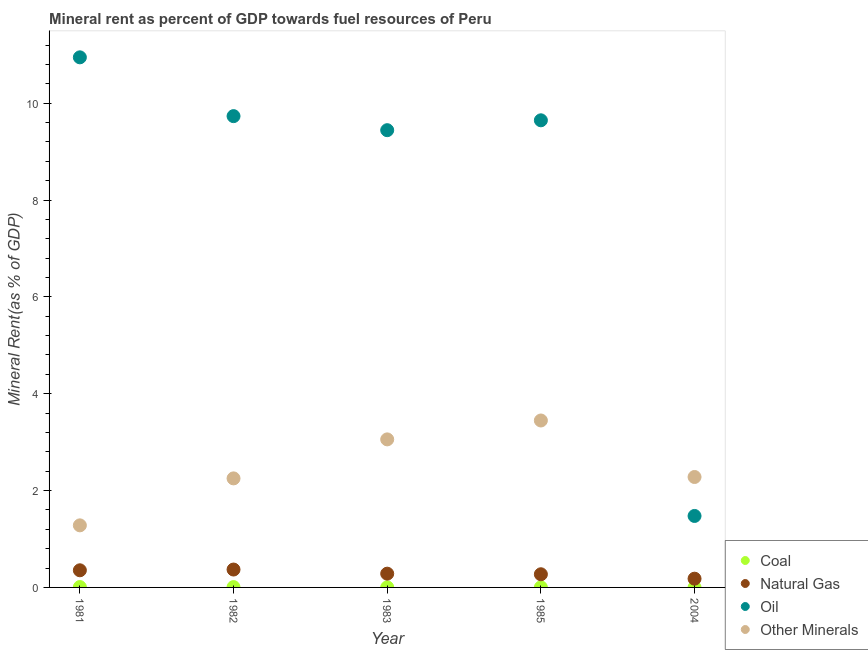How many different coloured dotlines are there?
Your response must be concise. 4. Is the number of dotlines equal to the number of legend labels?
Offer a terse response. Yes. What is the coal rent in 1985?
Ensure brevity in your answer.  0. Across all years, what is the maximum coal rent?
Your answer should be very brief. 0.01. Across all years, what is the minimum coal rent?
Provide a short and direct response. 0. In which year was the oil rent minimum?
Your answer should be very brief. 2004. What is the total oil rent in the graph?
Keep it short and to the point. 41.24. What is the difference between the coal rent in 1981 and that in 1985?
Offer a very short reply. 0.01. What is the difference between the natural gas rent in 1981 and the coal rent in 2004?
Offer a very short reply. 0.35. What is the average  rent of other minerals per year?
Your answer should be compact. 2.46. In the year 1982, what is the difference between the natural gas rent and coal rent?
Your response must be concise. 0.36. What is the ratio of the coal rent in 1981 to that in 1983?
Offer a terse response. 3.55. Is the difference between the oil rent in 1983 and 2004 greater than the difference between the natural gas rent in 1983 and 2004?
Keep it short and to the point. Yes. What is the difference between the highest and the second highest coal rent?
Give a very brief answer. 0. What is the difference between the highest and the lowest natural gas rent?
Give a very brief answer. 0.19. Is it the case that in every year, the sum of the coal rent and natural gas rent is greater than the oil rent?
Provide a short and direct response. No. Does the coal rent monotonically increase over the years?
Give a very brief answer. No. Is the oil rent strictly greater than the natural gas rent over the years?
Keep it short and to the point. Yes. How many years are there in the graph?
Ensure brevity in your answer.  5. Where does the legend appear in the graph?
Offer a very short reply. Bottom right. How many legend labels are there?
Keep it short and to the point. 4. What is the title of the graph?
Offer a very short reply. Mineral rent as percent of GDP towards fuel resources of Peru. What is the label or title of the X-axis?
Offer a terse response. Year. What is the label or title of the Y-axis?
Ensure brevity in your answer.  Mineral Rent(as % of GDP). What is the Mineral Rent(as % of GDP) in Coal in 1981?
Provide a succinct answer. 0.01. What is the Mineral Rent(as % of GDP) of Natural Gas in 1981?
Provide a succinct answer. 0.35. What is the Mineral Rent(as % of GDP) of Oil in 1981?
Offer a very short reply. 10.95. What is the Mineral Rent(as % of GDP) in Other Minerals in 1981?
Give a very brief answer. 1.28. What is the Mineral Rent(as % of GDP) of Coal in 1982?
Give a very brief answer. 0.01. What is the Mineral Rent(as % of GDP) in Natural Gas in 1982?
Provide a short and direct response. 0.37. What is the Mineral Rent(as % of GDP) in Oil in 1982?
Provide a succinct answer. 9.73. What is the Mineral Rent(as % of GDP) in Other Minerals in 1982?
Your answer should be compact. 2.25. What is the Mineral Rent(as % of GDP) in Coal in 1983?
Give a very brief answer. 0. What is the Mineral Rent(as % of GDP) in Natural Gas in 1983?
Provide a short and direct response. 0.28. What is the Mineral Rent(as % of GDP) of Oil in 1983?
Your answer should be compact. 9.44. What is the Mineral Rent(as % of GDP) in Other Minerals in 1983?
Offer a terse response. 3.06. What is the Mineral Rent(as % of GDP) in Coal in 1985?
Ensure brevity in your answer.  0. What is the Mineral Rent(as % of GDP) in Natural Gas in 1985?
Ensure brevity in your answer.  0.27. What is the Mineral Rent(as % of GDP) of Oil in 1985?
Your response must be concise. 9.65. What is the Mineral Rent(as % of GDP) in Other Minerals in 1985?
Offer a very short reply. 3.45. What is the Mineral Rent(as % of GDP) of Coal in 2004?
Your answer should be compact. 0. What is the Mineral Rent(as % of GDP) of Natural Gas in 2004?
Make the answer very short. 0.18. What is the Mineral Rent(as % of GDP) of Oil in 2004?
Make the answer very short. 1.48. What is the Mineral Rent(as % of GDP) of Other Minerals in 2004?
Give a very brief answer. 2.28. Across all years, what is the maximum Mineral Rent(as % of GDP) in Coal?
Ensure brevity in your answer.  0.01. Across all years, what is the maximum Mineral Rent(as % of GDP) of Natural Gas?
Offer a very short reply. 0.37. Across all years, what is the maximum Mineral Rent(as % of GDP) of Oil?
Provide a succinct answer. 10.95. Across all years, what is the maximum Mineral Rent(as % of GDP) of Other Minerals?
Offer a terse response. 3.45. Across all years, what is the minimum Mineral Rent(as % of GDP) of Coal?
Provide a short and direct response. 0. Across all years, what is the minimum Mineral Rent(as % of GDP) in Natural Gas?
Give a very brief answer. 0.18. Across all years, what is the minimum Mineral Rent(as % of GDP) in Oil?
Your answer should be very brief. 1.48. Across all years, what is the minimum Mineral Rent(as % of GDP) in Other Minerals?
Your answer should be compact. 1.28. What is the total Mineral Rent(as % of GDP) of Coal in the graph?
Your answer should be very brief. 0.02. What is the total Mineral Rent(as % of GDP) of Natural Gas in the graph?
Make the answer very short. 1.46. What is the total Mineral Rent(as % of GDP) of Oil in the graph?
Offer a very short reply. 41.24. What is the total Mineral Rent(as % of GDP) in Other Minerals in the graph?
Provide a short and direct response. 12.32. What is the difference between the Mineral Rent(as % of GDP) in Coal in 1981 and that in 1982?
Your answer should be very brief. 0. What is the difference between the Mineral Rent(as % of GDP) in Natural Gas in 1981 and that in 1982?
Keep it short and to the point. -0.02. What is the difference between the Mineral Rent(as % of GDP) in Oil in 1981 and that in 1982?
Provide a succinct answer. 1.21. What is the difference between the Mineral Rent(as % of GDP) in Other Minerals in 1981 and that in 1982?
Your answer should be compact. -0.97. What is the difference between the Mineral Rent(as % of GDP) of Coal in 1981 and that in 1983?
Your response must be concise. 0.01. What is the difference between the Mineral Rent(as % of GDP) in Natural Gas in 1981 and that in 1983?
Give a very brief answer. 0.07. What is the difference between the Mineral Rent(as % of GDP) in Oil in 1981 and that in 1983?
Offer a terse response. 1.5. What is the difference between the Mineral Rent(as % of GDP) of Other Minerals in 1981 and that in 1983?
Your response must be concise. -1.78. What is the difference between the Mineral Rent(as % of GDP) of Coal in 1981 and that in 1985?
Give a very brief answer. 0.01. What is the difference between the Mineral Rent(as % of GDP) of Natural Gas in 1981 and that in 1985?
Your response must be concise. 0.08. What is the difference between the Mineral Rent(as % of GDP) of Oil in 1981 and that in 1985?
Keep it short and to the point. 1.3. What is the difference between the Mineral Rent(as % of GDP) of Other Minerals in 1981 and that in 1985?
Make the answer very short. -2.17. What is the difference between the Mineral Rent(as % of GDP) of Coal in 1981 and that in 2004?
Offer a terse response. 0.01. What is the difference between the Mineral Rent(as % of GDP) of Natural Gas in 1981 and that in 2004?
Provide a short and direct response. 0.17. What is the difference between the Mineral Rent(as % of GDP) in Oil in 1981 and that in 2004?
Provide a succinct answer. 9.47. What is the difference between the Mineral Rent(as % of GDP) of Other Minerals in 1981 and that in 2004?
Make the answer very short. -1. What is the difference between the Mineral Rent(as % of GDP) in Coal in 1982 and that in 1983?
Your response must be concise. 0. What is the difference between the Mineral Rent(as % of GDP) of Natural Gas in 1982 and that in 1983?
Offer a terse response. 0.09. What is the difference between the Mineral Rent(as % of GDP) of Oil in 1982 and that in 1983?
Your answer should be compact. 0.29. What is the difference between the Mineral Rent(as % of GDP) of Other Minerals in 1982 and that in 1983?
Provide a short and direct response. -0.81. What is the difference between the Mineral Rent(as % of GDP) in Coal in 1982 and that in 1985?
Offer a very short reply. 0.01. What is the difference between the Mineral Rent(as % of GDP) of Natural Gas in 1982 and that in 1985?
Offer a terse response. 0.1. What is the difference between the Mineral Rent(as % of GDP) in Oil in 1982 and that in 1985?
Offer a very short reply. 0.09. What is the difference between the Mineral Rent(as % of GDP) of Other Minerals in 1982 and that in 1985?
Your answer should be very brief. -1.2. What is the difference between the Mineral Rent(as % of GDP) of Coal in 1982 and that in 2004?
Offer a terse response. 0.01. What is the difference between the Mineral Rent(as % of GDP) of Natural Gas in 1982 and that in 2004?
Offer a terse response. 0.19. What is the difference between the Mineral Rent(as % of GDP) in Oil in 1982 and that in 2004?
Offer a very short reply. 8.26. What is the difference between the Mineral Rent(as % of GDP) of Other Minerals in 1982 and that in 2004?
Your answer should be compact. -0.03. What is the difference between the Mineral Rent(as % of GDP) of Coal in 1983 and that in 1985?
Provide a short and direct response. 0. What is the difference between the Mineral Rent(as % of GDP) in Natural Gas in 1983 and that in 1985?
Provide a succinct answer. 0.01. What is the difference between the Mineral Rent(as % of GDP) in Oil in 1983 and that in 1985?
Your answer should be very brief. -0.2. What is the difference between the Mineral Rent(as % of GDP) in Other Minerals in 1983 and that in 1985?
Your answer should be very brief. -0.39. What is the difference between the Mineral Rent(as % of GDP) of Coal in 1983 and that in 2004?
Your answer should be very brief. 0. What is the difference between the Mineral Rent(as % of GDP) in Natural Gas in 1983 and that in 2004?
Your answer should be very brief. 0.1. What is the difference between the Mineral Rent(as % of GDP) in Oil in 1983 and that in 2004?
Make the answer very short. 7.97. What is the difference between the Mineral Rent(as % of GDP) of Other Minerals in 1983 and that in 2004?
Offer a very short reply. 0.78. What is the difference between the Mineral Rent(as % of GDP) in Coal in 1985 and that in 2004?
Provide a short and direct response. 0. What is the difference between the Mineral Rent(as % of GDP) in Natural Gas in 1985 and that in 2004?
Provide a succinct answer. 0.09. What is the difference between the Mineral Rent(as % of GDP) in Oil in 1985 and that in 2004?
Ensure brevity in your answer.  8.17. What is the difference between the Mineral Rent(as % of GDP) of Other Minerals in 1985 and that in 2004?
Your answer should be compact. 1.17. What is the difference between the Mineral Rent(as % of GDP) in Coal in 1981 and the Mineral Rent(as % of GDP) in Natural Gas in 1982?
Provide a short and direct response. -0.36. What is the difference between the Mineral Rent(as % of GDP) in Coal in 1981 and the Mineral Rent(as % of GDP) in Oil in 1982?
Offer a terse response. -9.72. What is the difference between the Mineral Rent(as % of GDP) in Coal in 1981 and the Mineral Rent(as % of GDP) in Other Minerals in 1982?
Offer a very short reply. -2.24. What is the difference between the Mineral Rent(as % of GDP) of Natural Gas in 1981 and the Mineral Rent(as % of GDP) of Oil in 1982?
Make the answer very short. -9.38. What is the difference between the Mineral Rent(as % of GDP) of Natural Gas in 1981 and the Mineral Rent(as % of GDP) of Other Minerals in 1982?
Your response must be concise. -1.9. What is the difference between the Mineral Rent(as % of GDP) in Oil in 1981 and the Mineral Rent(as % of GDP) in Other Minerals in 1982?
Your answer should be very brief. 8.69. What is the difference between the Mineral Rent(as % of GDP) of Coal in 1981 and the Mineral Rent(as % of GDP) of Natural Gas in 1983?
Offer a very short reply. -0.28. What is the difference between the Mineral Rent(as % of GDP) of Coal in 1981 and the Mineral Rent(as % of GDP) of Oil in 1983?
Offer a very short reply. -9.43. What is the difference between the Mineral Rent(as % of GDP) of Coal in 1981 and the Mineral Rent(as % of GDP) of Other Minerals in 1983?
Keep it short and to the point. -3.05. What is the difference between the Mineral Rent(as % of GDP) in Natural Gas in 1981 and the Mineral Rent(as % of GDP) in Oil in 1983?
Keep it short and to the point. -9.09. What is the difference between the Mineral Rent(as % of GDP) of Natural Gas in 1981 and the Mineral Rent(as % of GDP) of Other Minerals in 1983?
Offer a very short reply. -2.7. What is the difference between the Mineral Rent(as % of GDP) of Oil in 1981 and the Mineral Rent(as % of GDP) of Other Minerals in 1983?
Keep it short and to the point. 7.89. What is the difference between the Mineral Rent(as % of GDP) in Coal in 1981 and the Mineral Rent(as % of GDP) in Natural Gas in 1985?
Offer a very short reply. -0.26. What is the difference between the Mineral Rent(as % of GDP) of Coal in 1981 and the Mineral Rent(as % of GDP) of Oil in 1985?
Offer a very short reply. -9.64. What is the difference between the Mineral Rent(as % of GDP) in Coal in 1981 and the Mineral Rent(as % of GDP) in Other Minerals in 1985?
Your response must be concise. -3.44. What is the difference between the Mineral Rent(as % of GDP) of Natural Gas in 1981 and the Mineral Rent(as % of GDP) of Oil in 1985?
Ensure brevity in your answer.  -9.29. What is the difference between the Mineral Rent(as % of GDP) in Natural Gas in 1981 and the Mineral Rent(as % of GDP) in Other Minerals in 1985?
Ensure brevity in your answer.  -3.09. What is the difference between the Mineral Rent(as % of GDP) of Oil in 1981 and the Mineral Rent(as % of GDP) of Other Minerals in 1985?
Provide a succinct answer. 7.5. What is the difference between the Mineral Rent(as % of GDP) of Coal in 1981 and the Mineral Rent(as % of GDP) of Natural Gas in 2004?
Your answer should be very brief. -0.17. What is the difference between the Mineral Rent(as % of GDP) in Coal in 1981 and the Mineral Rent(as % of GDP) in Oil in 2004?
Keep it short and to the point. -1.47. What is the difference between the Mineral Rent(as % of GDP) in Coal in 1981 and the Mineral Rent(as % of GDP) in Other Minerals in 2004?
Offer a very short reply. -2.27. What is the difference between the Mineral Rent(as % of GDP) in Natural Gas in 1981 and the Mineral Rent(as % of GDP) in Oil in 2004?
Your answer should be compact. -1.12. What is the difference between the Mineral Rent(as % of GDP) of Natural Gas in 1981 and the Mineral Rent(as % of GDP) of Other Minerals in 2004?
Your answer should be very brief. -1.93. What is the difference between the Mineral Rent(as % of GDP) in Oil in 1981 and the Mineral Rent(as % of GDP) in Other Minerals in 2004?
Offer a very short reply. 8.67. What is the difference between the Mineral Rent(as % of GDP) in Coal in 1982 and the Mineral Rent(as % of GDP) in Natural Gas in 1983?
Provide a succinct answer. -0.28. What is the difference between the Mineral Rent(as % of GDP) of Coal in 1982 and the Mineral Rent(as % of GDP) of Oil in 1983?
Give a very brief answer. -9.44. What is the difference between the Mineral Rent(as % of GDP) of Coal in 1982 and the Mineral Rent(as % of GDP) of Other Minerals in 1983?
Your answer should be very brief. -3.05. What is the difference between the Mineral Rent(as % of GDP) of Natural Gas in 1982 and the Mineral Rent(as % of GDP) of Oil in 1983?
Ensure brevity in your answer.  -9.07. What is the difference between the Mineral Rent(as % of GDP) in Natural Gas in 1982 and the Mineral Rent(as % of GDP) in Other Minerals in 1983?
Provide a succinct answer. -2.69. What is the difference between the Mineral Rent(as % of GDP) in Oil in 1982 and the Mineral Rent(as % of GDP) in Other Minerals in 1983?
Give a very brief answer. 6.68. What is the difference between the Mineral Rent(as % of GDP) in Coal in 1982 and the Mineral Rent(as % of GDP) in Natural Gas in 1985?
Offer a terse response. -0.27. What is the difference between the Mineral Rent(as % of GDP) in Coal in 1982 and the Mineral Rent(as % of GDP) in Oil in 1985?
Your response must be concise. -9.64. What is the difference between the Mineral Rent(as % of GDP) of Coal in 1982 and the Mineral Rent(as % of GDP) of Other Minerals in 1985?
Your answer should be very brief. -3.44. What is the difference between the Mineral Rent(as % of GDP) of Natural Gas in 1982 and the Mineral Rent(as % of GDP) of Oil in 1985?
Your response must be concise. -9.28. What is the difference between the Mineral Rent(as % of GDP) of Natural Gas in 1982 and the Mineral Rent(as % of GDP) of Other Minerals in 1985?
Offer a terse response. -3.08. What is the difference between the Mineral Rent(as % of GDP) of Oil in 1982 and the Mineral Rent(as % of GDP) of Other Minerals in 1985?
Your response must be concise. 6.29. What is the difference between the Mineral Rent(as % of GDP) in Coal in 1982 and the Mineral Rent(as % of GDP) in Natural Gas in 2004?
Ensure brevity in your answer.  -0.17. What is the difference between the Mineral Rent(as % of GDP) in Coal in 1982 and the Mineral Rent(as % of GDP) in Oil in 2004?
Keep it short and to the point. -1.47. What is the difference between the Mineral Rent(as % of GDP) of Coal in 1982 and the Mineral Rent(as % of GDP) of Other Minerals in 2004?
Provide a short and direct response. -2.27. What is the difference between the Mineral Rent(as % of GDP) in Natural Gas in 1982 and the Mineral Rent(as % of GDP) in Oil in 2004?
Give a very brief answer. -1.11. What is the difference between the Mineral Rent(as % of GDP) in Natural Gas in 1982 and the Mineral Rent(as % of GDP) in Other Minerals in 2004?
Your answer should be very brief. -1.91. What is the difference between the Mineral Rent(as % of GDP) of Oil in 1982 and the Mineral Rent(as % of GDP) of Other Minerals in 2004?
Provide a short and direct response. 7.45. What is the difference between the Mineral Rent(as % of GDP) of Coal in 1983 and the Mineral Rent(as % of GDP) of Natural Gas in 1985?
Offer a terse response. -0.27. What is the difference between the Mineral Rent(as % of GDP) of Coal in 1983 and the Mineral Rent(as % of GDP) of Oil in 1985?
Make the answer very short. -9.64. What is the difference between the Mineral Rent(as % of GDP) in Coal in 1983 and the Mineral Rent(as % of GDP) in Other Minerals in 1985?
Your response must be concise. -3.44. What is the difference between the Mineral Rent(as % of GDP) in Natural Gas in 1983 and the Mineral Rent(as % of GDP) in Oil in 1985?
Provide a succinct answer. -9.36. What is the difference between the Mineral Rent(as % of GDP) of Natural Gas in 1983 and the Mineral Rent(as % of GDP) of Other Minerals in 1985?
Your answer should be very brief. -3.16. What is the difference between the Mineral Rent(as % of GDP) of Oil in 1983 and the Mineral Rent(as % of GDP) of Other Minerals in 1985?
Give a very brief answer. 6. What is the difference between the Mineral Rent(as % of GDP) in Coal in 1983 and the Mineral Rent(as % of GDP) in Natural Gas in 2004?
Give a very brief answer. -0.18. What is the difference between the Mineral Rent(as % of GDP) of Coal in 1983 and the Mineral Rent(as % of GDP) of Oil in 2004?
Your response must be concise. -1.47. What is the difference between the Mineral Rent(as % of GDP) in Coal in 1983 and the Mineral Rent(as % of GDP) in Other Minerals in 2004?
Ensure brevity in your answer.  -2.28. What is the difference between the Mineral Rent(as % of GDP) in Natural Gas in 1983 and the Mineral Rent(as % of GDP) in Oil in 2004?
Provide a short and direct response. -1.19. What is the difference between the Mineral Rent(as % of GDP) in Natural Gas in 1983 and the Mineral Rent(as % of GDP) in Other Minerals in 2004?
Provide a short and direct response. -2. What is the difference between the Mineral Rent(as % of GDP) of Oil in 1983 and the Mineral Rent(as % of GDP) of Other Minerals in 2004?
Your answer should be very brief. 7.16. What is the difference between the Mineral Rent(as % of GDP) of Coal in 1985 and the Mineral Rent(as % of GDP) of Natural Gas in 2004?
Ensure brevity in your answer.  -0.18. What is the difference between the Mineral Rent(as % of GDP) in Coal in 1985 and the Mineral Rent(as % of GDP) in Oil in 2004?
Your answer should be very brief. -1.47. What is the difference between the Mineral Rent(as % of GDP) in Coal in 1985 and the Mineral Rent(as % of GDP) in Other Minerals in 2004?
Give a very brief answer. -2.28. What is the difference between the Mineral Rent(as % of GDP) in Natural Gas in 1985 and the Mineral Rent(as % of GDP) in Oil in 2004?
Your response must be concise. -1.2. What is the difference between the Mineral Rent(as % of GDP) of Natural Gas in 1985 and the Mineral Rent(as % of GDP) of Other Minerals in 2004?
Give a very brief answer. -2.01. What is the difference between the Mineral Rent(as % of GDP) of Oil in 1985 and the Mineral Rent(as % of GDP) of Other Minerals in 2004?
Provide a short and direct response. 7.37. What is the average Mineral Rent(as % of GDP) in Coal per year?
Offer a terse response. 0. What is the average Mineral Rent(as % of GDP) of Natural Gas per year?
Make the answer very short. 0.29. What is the average Mineral Rent(as % of GDP) in Oil per year?
Ensure brevity in your answer.  8.25. What is the average Mineral Rent(as % of GDP) in Other Minerals per year?
Offer a very short reply. 2.46. In the year 1981, what is the difference between the Mineral Rent(as % of GDP) in Coal and Mineral Rent(as % of GDP) in Natural Gas?
Make the answer very short. -0.35. In the year 1981, what is the difference between the Mineral Rent(as % of GDP) of Coal and Mineral Rent(as % of GDP) of Oil?
Your answer should be compact. -10.94. In the year 1981, what is the difference between the Mineral Rent(as % of GDP) in Coal and Mineral Rent(as % of GDP) in Other Minerals?
Keep it short and to the point. -1.27. In the year 1981, what is the difference between the Mineral Rent(as % of GDP) in Natural Gas and Mineral Rent(as % of GDP) in Oil?
Offer a terse response. -10.59. In the year 1981, what is the difference between the Mineral Rent(as % of GDP) of Natural Gas and Mineral Rent(as % of GDP) of Other Minerals?
Make the answer very short. -0.93. In the year 1981, what is the difference between the Mineral Rent(as % of GDP) in Oil and Mineral Rent(as % of GDP) in Other Minerals?
Give a very brief answer. 9.66. In the year 1982, what is the difference between the Mineral Rent(as % of GDP) of Coal and Mineral Rent(as % of GDP) of Natural Gas?
Provide a succinct answer. -0.36. In the year 1982, what is the difference between the Mineral Rent(as % of GDP) of Coal and Mineral Rent(as % of GDP) of Oil?
Give a very brief answer. -9.73. In the year 1982, what is the difference between the Mineral Rent(as % of GDP) in Coal and Mineral Rent(as % of GDP) in Other Minerals?
Give a very brief answer. -2.24. In the year 1982, what is the difference between the Mineral Rent(as % of GDP) in Natural Gas and Mineral Rent(as % of GDP) in Oil?
Offer a terse response. -9.36. In the year 1982, what is the difference between the Mineral Rent(as % of GDP) in Natural Gas and Mineral Rent(as % of GDP) in Other Minerals?
Make the answer very short. -1.88. In the year 1982, what is the difference between the Mineral Rent(as % of GDP) in Oil and Mineral Rent(as % of GDP) in Other Minerals?
Your answer should be very brief. 7.48. In the year 1983, what is the difference between the Mineral Rent(as % of GDP) in Coal and Mineral Rent(as % of GDP) in Natural Gas?
Keep it short and to the point. -0.28. In the year 1983, what is the difference between the Mineral Rent(as % of GDP) of Coal and Mineral Rent(as % of GDP) of Oil?
Your answer should be compact. -9.44. In the year 1983, what is the difference between the Mineral Rent(as % of GDP) of Coal and Mineral Rent(as % of GDP) of Other Minerals?
Your answer should be very brief. -3.05. In the year 1983, what is the difference between the Mineral Rent(as % of GDP) in Natural Gas and Mineral Rent(as % of GDP) in Oil?
Your response must be concise. -9.16. In the year 1983, what is the difference between the Mineral Rent(as % of GDP) in Natural Gas and Mineral Rent(as % of GDP) in Other Minerals?
Offer a terse response. -2.77. In the year 1983, what is the difference between the Mineral Rent(as % of GDP) of Oil and Mineral Rent(as % of GDP) of Other Minerals?
Provide a succinct answer. 6.38. In the year 1985, what is the difference between the Mineral Rent(as % of GDP) of Coal and Mineral Rent(as % of GDP) of Natural Gas?
Offer a very short reply. -0.27. In the year 1985, what is the difference between the Mineral Rent(as % of GDP) of Coal and Mineral Rent(as % of GDP) of Oil?
Ensure brevity in your answer.  -9.64. In the year 1985, what is the difference between the Mineral Rent(as % of GDP) in Coal and Mineral Rent(as % of GDP) in Other Minerals?
Your response must be concise. -3.45. In the year 1985, what is the difference between the Mineral Rent(as % of GDP) of Natural Gas and Mineral Rent(as % of GDP) of Oil?
Keep it short and to the point. -9.37. In the year 1985, what is the difference between the Mineral Rent(as % of GDP) of Natural Gas and Mineral Rent(as % of GDP) of Other Minerals?
Keep it short and to the point. -3.18. In the year 1985, what is the difference between the Mineral Rent(as % of GDP) of Oil and Mineral Rent(as % of GDP) of Other Minerals?
Give a very brief answer. 6.2. In the year 2004, what is the difference between the Mineral Rent(as % of GDP) of Coal and Mineral Rent(as % of GDP) of Natural Gas?
Ensure brevity in your answer.  -0.18. In the year 2004, what is the difference between the Mineral Rent(as % of GDP) of Coal and Mineral Rent(as % of GDP) of Oil?
Provide a short and direct response. -1.48. In the year 2004, what is the difference between the Mineral Rent(as % of GDP) of Coal and Mineral Rent(as % of GDP) of Other Minerals?
Give a very brief answer. -2.28. In the year 2004, what is the difference between the Mineral Rent(as % of GDP) of Natural Gas and Mineral Rent(as % of GDP) of Oil?
Provide a short and direct response. -1.3. In the year 2004, what is the difference between the Mineral Rent(as % of GDP) of Natural Gas and Mineral Rent(as % of GDP) of Other Minerals?
Provide a short and direct response. -2.1. In the year 2004, what is the difference between the Mineral Rent(as % of GDP) of Oil and Mineral Rent(as % of GDP) of Other Minerals?
Ensure brevity in your answer.  -0.8. What is the ratio of the Mineral Rent(as % of GDP) of Coal in 1981 to that in 1982?
Provide a short and direct response. 1.15. What is the ratio of the Mineral Rent(as % of GDP) in Natural Gas in 1981 to that in 1982?
Keep it short and to the point. 0.96. What is the ratio of the Mineral Rent(as % of GDP) in Oil in 1981 to that in 1982?
Provide a succinct answer. 1.12. What is the ratio of the Mineral Rent(as % of GDP) in Other Minerals in 1981 to that in 1982?
Offer a terse response. 0.57. What is the ratio of the Mineral Rent(as % of GDP) in Coal in 1981 to that in 1983?
Ensure brevity in your answer.  3.55. What is the ratio of the Mineral Rent(as % of GDP) in Natural Gas in 1981 to that in 1983?
Your response must be concise. 1.25. What is the ratio of the Mineral Rent(as % of GDP) of Oil in 1981 to that in 1983?
Ensure brevity in your answer.  1.16. What is the ratio of the Mineral Rent(as % of GDP) of Other Minerals in 1981 to that in 1983?
Your response must be concise. 0.42. What is the ratio of the Mineral Rent(as % of GDP) of Coal in 1981 to that in 1985?
Make the answer very short. 4.89. What is the ratio of the Mineral Rent(as % of GDP) in Natural Gas in 1981 to that in 1985?
Ensure brevity in your answer.  1.3. What is the ratio of the Mineral Rent(as % of GDP) in Oil in 1981 to that in 1985?
Ensure brevity in your answer.  1.13. What is the ratio of the Mineral Rent(as % of GDP) in Other Minerals in 1981 to that in 1985?
Offer a terse response. 0.37. What is the ratio of the Mineral Rent(as % of GDP) of Coal in 1981 to that in 2004?
Your answer should be very brief. 18.64. What is the ratio of the Mineral Rent(as % of GDP) in Natural Gas in 1981 to that in 2004?
Your answer should be compact. 1.96. What is the ratio of the Mineral Rent(as % of GDP) of Oil in 1981 to that in 2004?
Keep it short and to the point. 7.42. What is the ratio of the Mineral Rent(as % of GDP) in Other Minerals in 1981 to that in 2004?
Give a very brief answer. 0.56. What is the ratio of the Mineral Rent(as % of GDP) of Coal in 1982 to that in 1983?
Provide a short and direct response. 3.09. What is the ratio of the Mineral Rent(as % of GDP) in Natural Gas in 1982 to that in 1983?
Ensure brevity in your answer.  1.3. What is the ratio of the Mineral Rent(as % of GDP) of Oil in 1982 to that in 1983?
Provide a succinct answer. 1.03. What is the ratio of the Mineral Rent(as % of GDP) of Other Minerals in 1982 to that in 1983?
Keep it short and to the point. 0.74. What is the ratio of the Mineral Rent(as % of GDP) of Coal in 1982 to that in 1985?
Your answer should be compact. 4.26. What is the ratio of the Mineral Rent(as % of GDP) of Natural Gas in 1982 to that in 1985?
Offer a terse response. 1.36. What is the ratio of the Mineral Rent(as % of GDP) of Oil in 1982 to that in 1985?
Provide a short and direct response. 1.01. What is the ratio of the Mineral Rent(as % of GDP) in Other Minerals in 1982 to that in 1985?
Offer a terse response. 0.65. What is the ratio of the Mineral Rent(as % of GDP) of Coal in 1982 to that in 2004?
Your response must be concise. 16.25. What is the ratio of the Mineral Rent(as % of GDP) of Natural Gas in 1982 to that in 2004?
Your answer should be compact. 2.04. What is the ratio of the Mineral Rent(as % of GDP) of Oil in 1982 to that in 2004?
Your answer should be very brief. 6.59. What is the ratio of the Mineral Rent(as % of GDP) in Other Minerals in 1982 to that in 2004?
Give a very brief answer. 0.99. What is the ratio of the Mineral Rent(as % of GDP) in Coal in 1983 to that in 1985?
Give a very brief answer. 1.38. What is the ratio of the Mineral Rent(as % of GDP) of Natural Gas in 1983 to that in 1985?
Offer a very short reply. 1.05. What is the ratio of the Mineral Rent(as % of GDP) of Oil in 1983 to that in 1985?
Provide a succinct answer. 0.98. What is the ratio of the Mineral Rent(as % of GDP) of Other Minerals in 1983 to that in 1985?
Ensure brevity in your answer.  0.89. What is the ratio of the Mineral Rent(as % of GDP) of Coal in 1983 to that in 2004?
Give a very brief answer. 5.25. What is the ratio of the Mineral Rent(as % of GDP) in Natural Gas in 1983 to that in 2004?
Offer a terse response. 1.57. What is the ratio of the Mineral Rent(as % of GDP) in Oil in 1983 to that in 2004?
Offer a terse response. 6.4. What is the ratio of the Mineral Rent(as % of GDP) in Other Minerals in 1983 to that in 2004?
Make the answer very short. 1.34. What is the ratio of the Mineral Rent(as % of GDP) of Coal in 1985 to that in 2004?
Your answer should be very brief. 3.81. What is the ratio of the Mineral Rent(as % of GDP) of Natural Gas in 1985 to that in 2004?
Keep it short and to the point. 1.5. What is the ratio of the Mineral Rent(as % of GDP) of Oil in 1985 to that in 2004?
Your answer should be very brief. 6.54. What is the ratio of the Mineral Rent(as % of GDP) in Other Minerals in 1985 to that in 2004?
Provide a short and direct response. 1.51. What is the difference between the highest and the second highest Mineral Rent(as % of GDP) in Coal?
Offer a very short reply. 0. What is the difference between the highest and the second highest Mineral Rent(as % of GDP) of Natural Gas?
Your answer should be compact. 0.02. What is the difference between the highest and the second highest Mineral Rent(as % of GDP) of Oil?
Provide a short and direct response. 1.21. What is the difference between the highest and the second highest Mineral Rent(as % of GDP) of Other Minerals?
Keep it short and to the point. 0.39. What is the difference between the highest and the lowest Mineral Rent(as % of GDP) of Coal?
Provide a short and direct response. 0.01. What is the difference between the highest and the lowest Mineral Rent(as % of GDP) in Natural Gas?
Give a very brief answer. 0.19. What is the difference between the highest and the lowest Mineral Rent(as % of GDP) of Oil?
Your answer should be compact. 9.47. What is the difference between the highest and the lowest Mineral Rent(as % of GDP) in Other Minerals?
Offer a terse response. 2.17. 